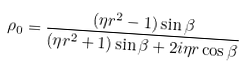Convert formula to latex. <formula><loc_0><loc_0><loc_500><loc_500>\rho _ { 0 } = \frac { ( \eta r ^ { 2 } - 1 ) \sin \beta } { ( \eta r ^ { 2 } + 1 ) \sin \beta + 2 i \eta r \cos \beta } \,</formula> 